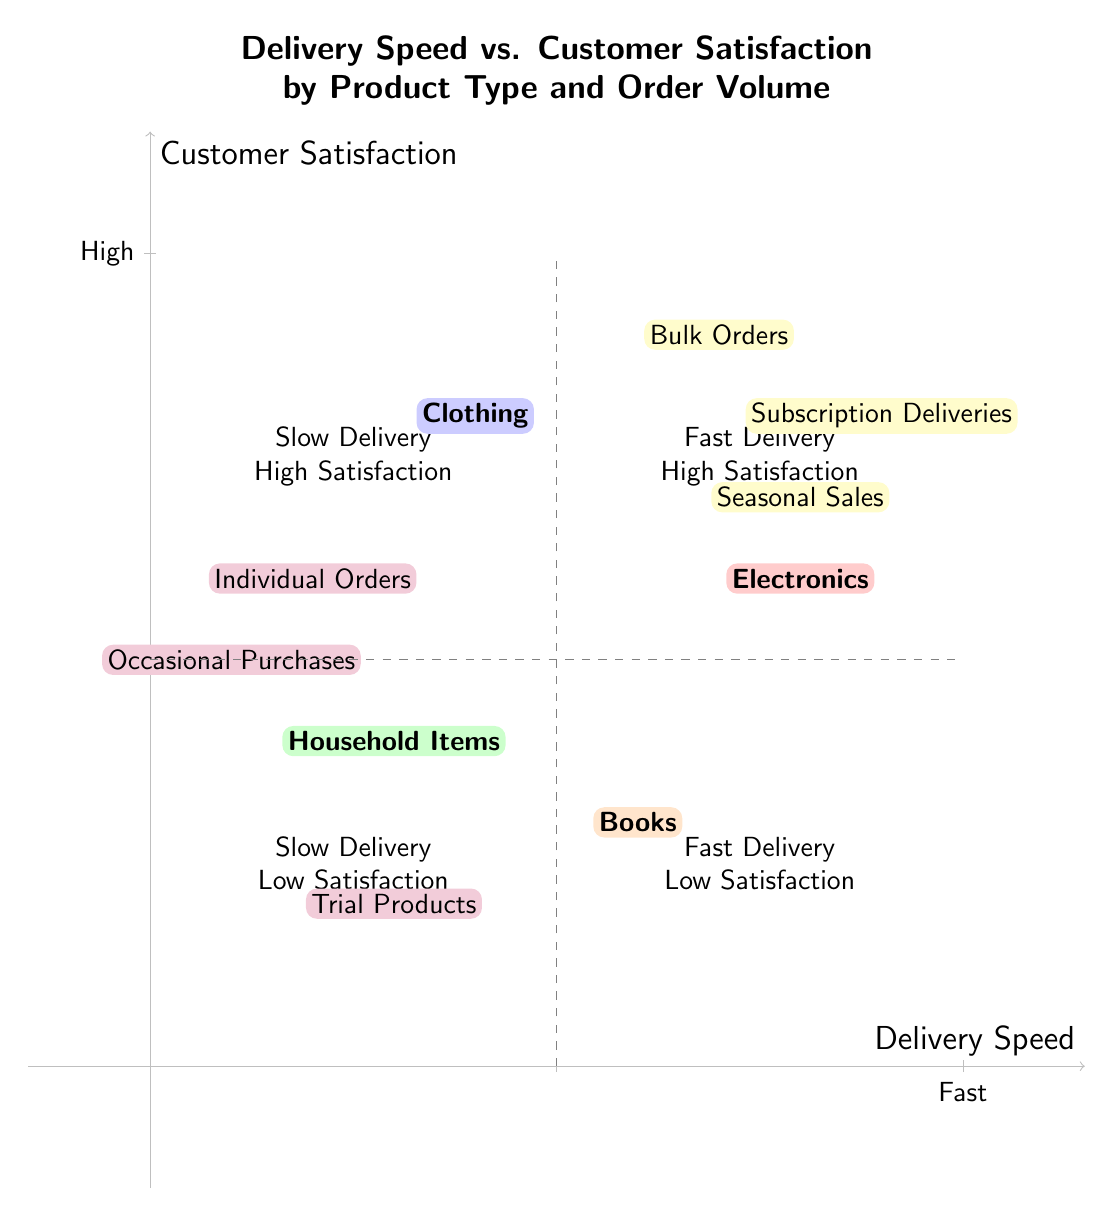What product type is located in Quadrant 1? In Quadrant 1, which corresponds to "High Fast Delivery - High Satisfaction", we can see the product type "Electronics" placed towards the top right of the quadrant.
Answer: Electronics What is the location of Household Items on the chart? The product type "Household Items" is positioned near (3, 4), which is in Quadrant 3 labeled "Slow Delivery - Low Satisfaction".
Answer: Quadrant 3 How many product types are represented in the diagram? The diagram shows four product types: Electronics, Clothing, Household Items, and Books, totaling four distinct product types.
Answer: Four Which order type has the highest delivery speed? When examining the quadrant classification, "Subscription Deliveries" appears in the top right region where the delivery speed is high, indicating it has the fastest delivery associated with high customer satisfaction.
Answer: Subscription Deliveries Compare the satisfaction levels of Products in Quadrant 2 and Quadrant 4. In Quadrant 2 ("Slow Delivery - High Satisfaction"), products like "Clothing" are present, indicating high satisfaction despite slower delivery. In Quadrant 4 ("High Fast Delivery - Low Satisfaction"), products like "Books" indicate low satisfaction, even with fast delivery. Thus, Quadrant 2 has higher satisfaction levels overall compared to Quadrant 4.
Answer: Quadrant 2 has higher satisfaction levels What type of orders are associated with low delivery speed? The product types "Individual Orders", "Occasional Purchases", and "Trial Products" are all associated with lower delivery speeds and can be found in the lower quadrants of the chart.
Answer: Individual Orders, Occasional Purchases, Trial Products Which quadrant has a product type with both high delivery speed and low satisfaction? Quadrant 4 represents a combination of high-speed delivery with low satisfaction, and it specifically includes the product type "Books".
Answer: Quadrant 4 What is the relationship between order volume and customer satisfaction for Household Items? "Household Items" is located in Quadrant 3, indicating it has low customer satisfaction. As for order volume, there are no specific high-volume indicators linked directly to it on the chart; thus, its order volume remains primarily low.
Answer: Low customer satisfaction Which product type falls into Quadrant 2 and what does it indicate? "Clothing" is the product type located in Quadrant 2, which indicates it has a slow delivery speed but high customer satisfaction, showing that customers are generally satisfied despite waiting longer for the product.
Answer: Clothing 